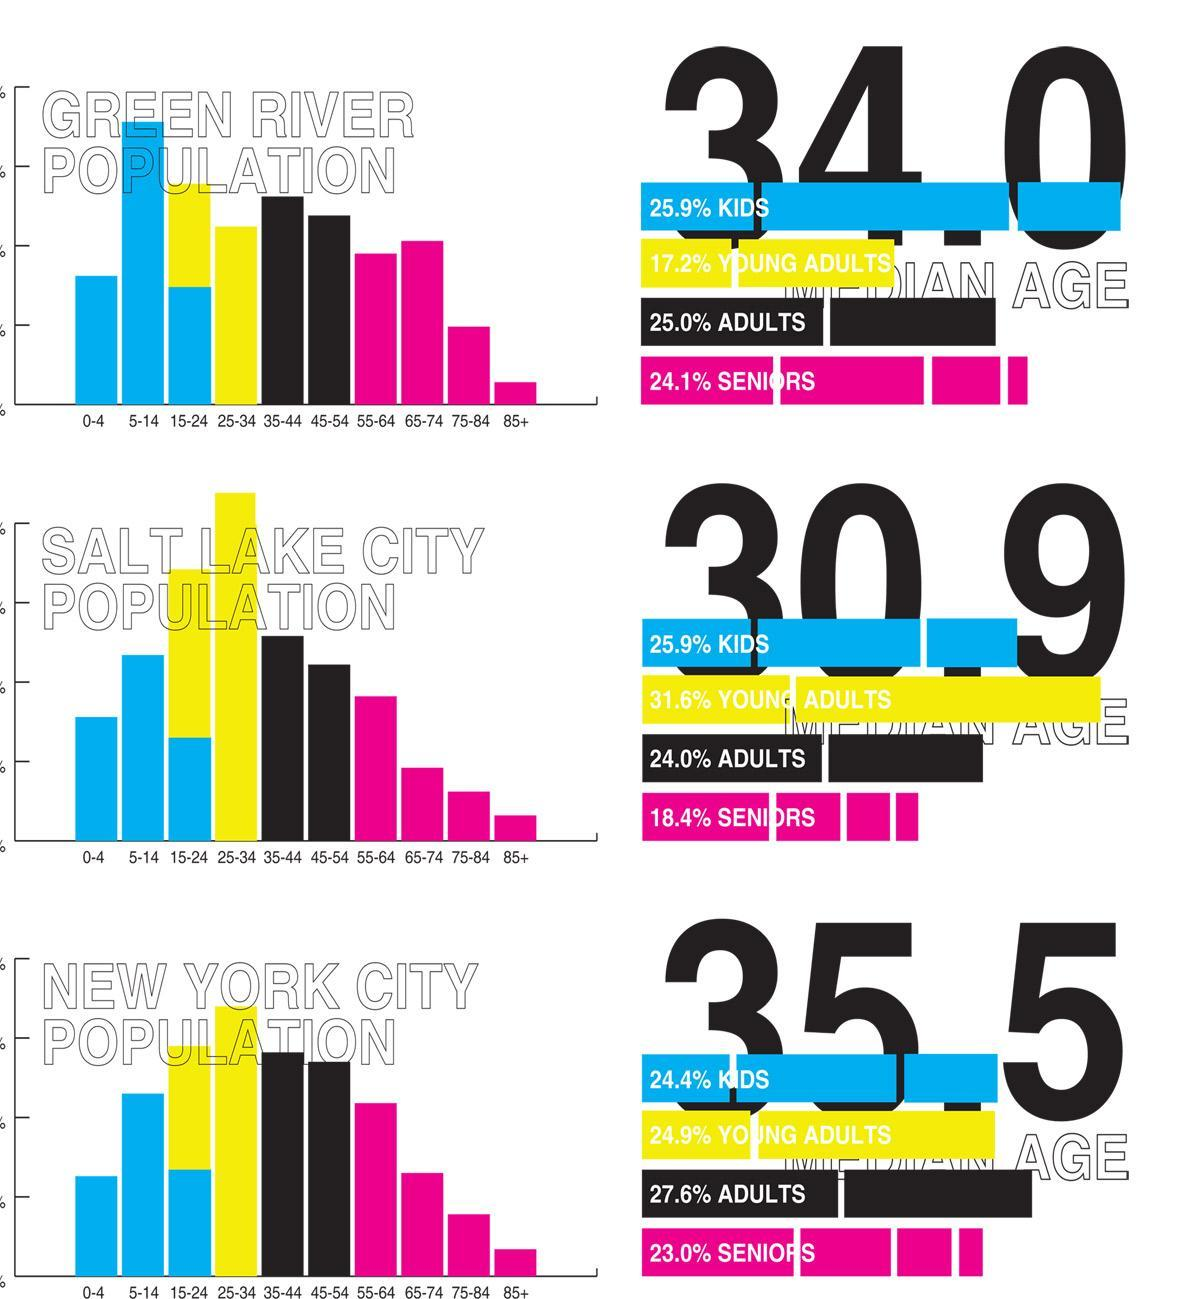what is the percentage of population of age below 35 In Green river?
Answer the question with a short phrase. 43.1% what is the percentage of population of age 35 or above In Salt Lake city? 42.4% what is the percentage of population of age below 55 In New York city? 76.9% what is the percentage of population of age between 35 and 54 In Green river? 25 what is the percentage of population of age 55 or above In Salt lake city? 18.4 what is the percentage of population of age 35 or above In New York city? 50.6% what is the percentage of population of age 55 or above In New York city? 23.0 what is the percentage of population of age 35 or above In Green river? 49.1% what is the percentage of population of age 55 or above In Green river? 24.1 what is the percentage of population of age below 55 In Green river? 68.1% what is the percentage of population of age below 55 In Salt Lake city? 81.5% what is the percentage of population of age below 35 In New York city? 49.3% what is the percentage of population of age between 35 and 54 In Salt lake city? 24.0% what is the percentage of population of age below 35 In Salt Lake city? 57.5 what is the percentage of population of age between 35 and 54 In New York city? 27.6 